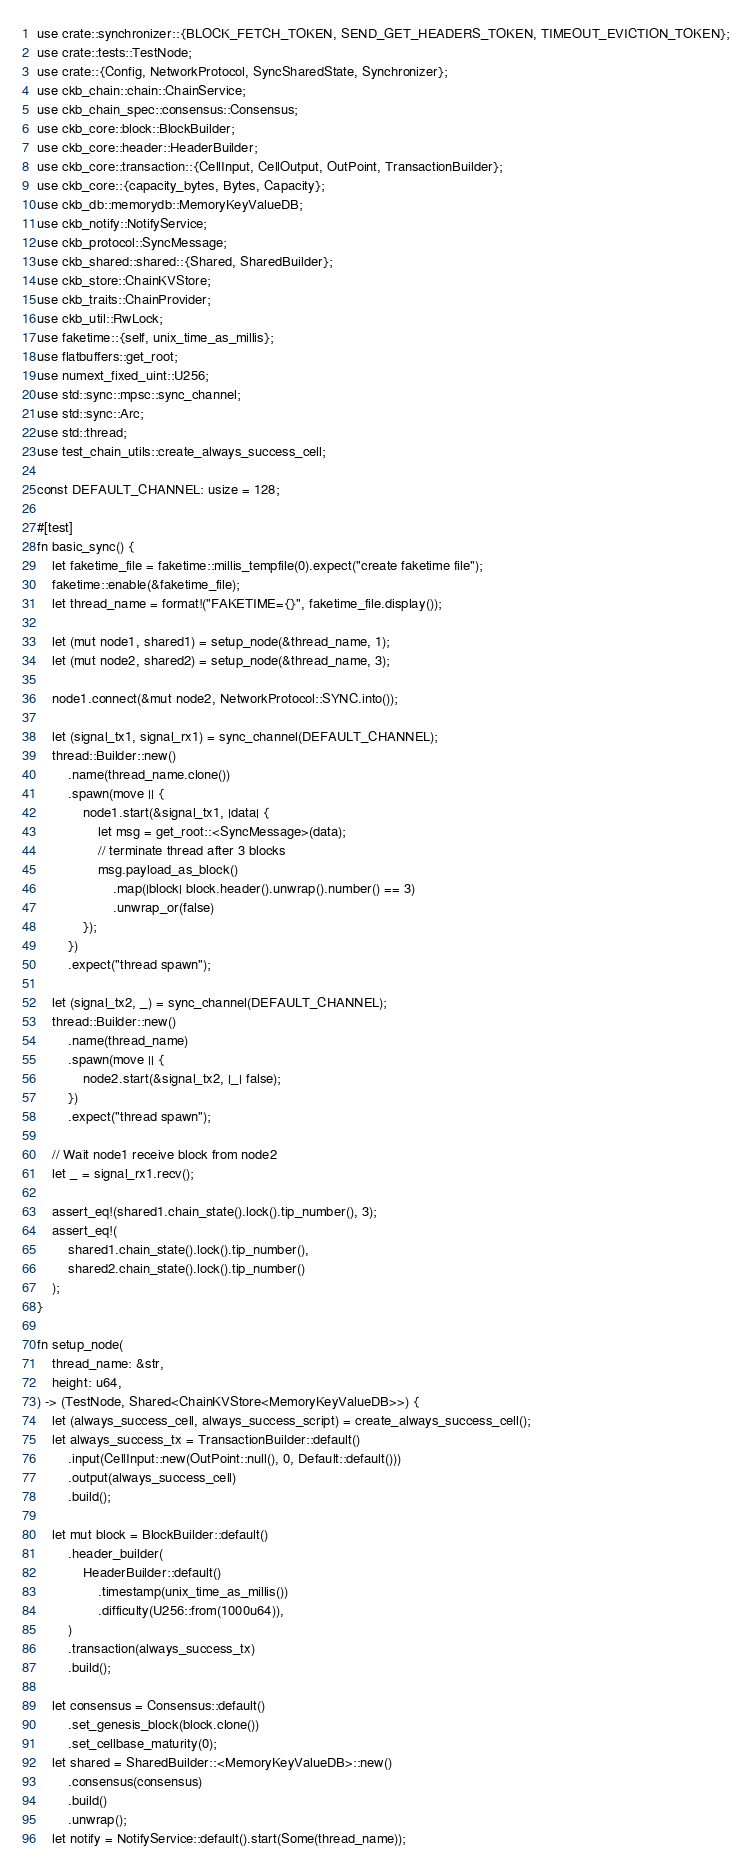Convert code to text. <code><loc_0><loc_0><loc_500><loc_500><_Rust_>use crate::synchronizer::{BLOCK_FETCH_TOKEN, SEND_GET_HEADERS_TOKEN, TIMEOUT_EVICTION_TOKEN};
use crate::tests::TestNode;
use crate::{Config, NetworkProtocol, SyncSharedState, Synchronizer};
use ckb_chain::chain::ChainService;
use ckb_chain_spec::consensus::Consensus;
use ckb_core::block::BlockBuilder;
use ckb_core::header::HeaderBuilder;
use ckb_core::transaction::{CellInput, CellOutput, OutPoint, TransactionBuilder};
use ckb_core::{capacity_bytes, Bytes, Capacity};
use ckb_db::memorydb::MemoryKeyValueDB;
use ckb_notify::NotifyService;
use ckb_protocol::SyncMessage;
use ckb_shared::shared::{Shared, SharedBuilder};
use ckb_store::ChainKVStore;
use ckb_traits::ChainProvider;
use ckb_util::RwLock;
use faketime::{self, unix_time_as_millis};
use flatbuffers::get_root;
use numext_fixed_uint::U256;
use std::sync::mpsc::sync_channel;
use std::sync::Arc;
use std::thread;
use test_chain_utils::create_always_success_cell;

const DEFAULT_CHANNEL: usize = 128;

#[test]
fn basic_sync() {
    let faketime_file = faketime::millis_tempfile(0).expect("create faketime file");
    faketime::enable(&faketime_file);
    let thread_name = format!("FAKETIME={}", faketime_file.display());

    let (mut node1, shared1) = setup_node(&thread_name, 1);
    let (mut node2, shared2) = setup_node(&thread_name, 3);

    node1.connect(&mut node2, NetworkProtocol::SYNC.into());

    let (signal_tx1, signal_rx1) = sync_channel(DEFAULT_CHANNEL);
    thread::Builder::new()
        .name(thread_name.clone())
        .spawn(move || {
            node1.start(&signal_tx1, |data| {
                let msg = get_root::<SyncMessage>(data);
                // terminate thread after 3 blocks
                msg.payload_as_block()
                    .map(|block| block.header().unwrap().number() == 3)
                    .unwrap_or(false)
            });
        })
        .expect("thread spawn");

    let (signal_tx2, _) = sync_channel(DEFAULT_CHANNEL);
    thread::Builder::new()
        .name(thread_name)
        .spawn(move || {
            node2.start(&signal_tx2, |_| false);
        })
        .expect("thread spawn");

    // Wait node1 receive block from node2
    let _ = signal_rx1.recv();

    assert_eq!(shared1.chain_state().lock().tip_number(), 3);
    assert_eq!(
        shared1.chain_state().lock().tip_number(),
        shared2.chain_state().lock().tip_number()
    );
}

fn setup_node(
    thread_name: &str,
    height: u64,
) -> (TestNode, Shared<ChainKVStore<MemoryKeyValueDB>>) {
    let (always_success_cell, always_success_script) = create_always_success_cell();
    let always_success_tx = TransactionBuilder::default()
        .input(CellInput::new(OutPoint::null(), 0, Default::default()))
        .output(always_success_cell)
        .build();

    let mut block = BlockBuilder::default()
        .header_builder(
            HeaderBuilder::default()
                .timestamp(unix_time_as_millis())
                .difficulty(U256::from(1000u64)),
        )
        .transaction(always_success_tx)
        .build();

    let consensus = Consensus::default()
        .set_genesis_block(block.clone())
        .set_cellbase_maturity(0);
    let shared = SharedBuilder::<MemoryKeyValueDB>::new()
        .consensus(consensus)
        .build()
        .unwrap();
    let notify = NotifyService::default().start(Some(thread_name));
</code> 